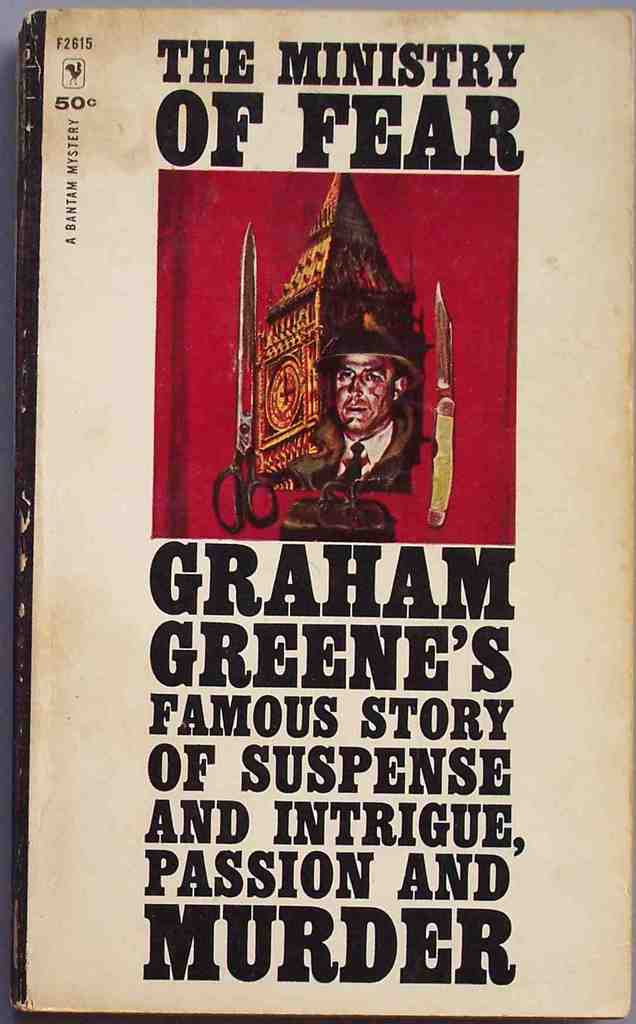How does the use of red and black colors on the book cover affect the perception of the story? The red and black color scheme on the book cover of 'The Ministry of Fear' evoke a sense of danger and mystery. Red often symbolizes passion, violence, and urgency, while black can suggest secrecy and the unknown. Combined, these colors effectively set a foreboding tone, hinting at the thrilling and perilous adventures that lie within the pages of the book. 